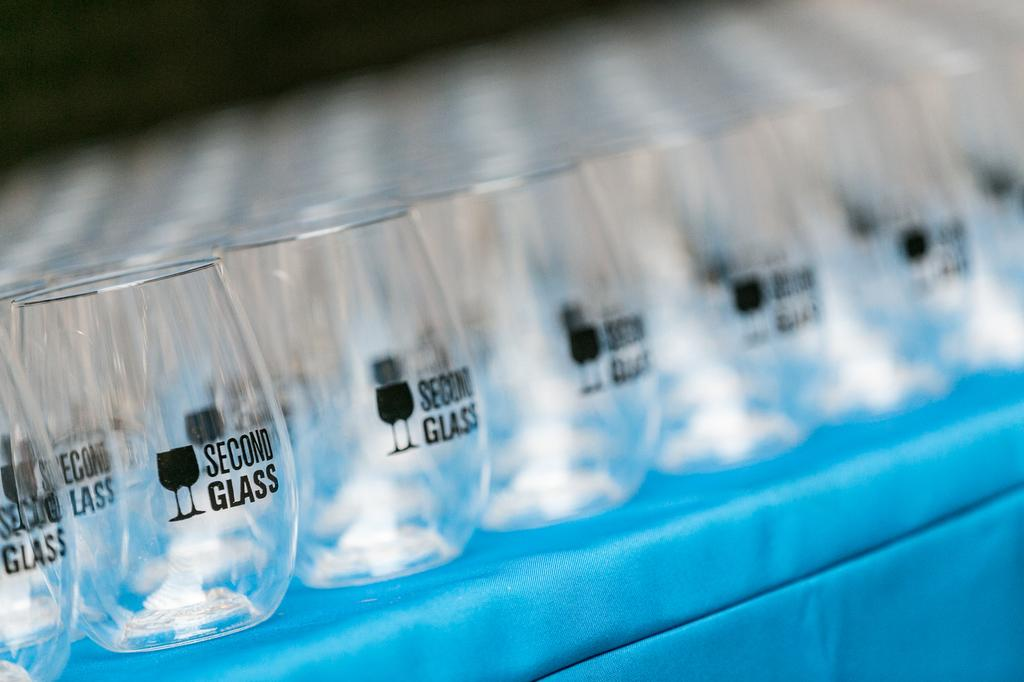Provide a one-sentence caption for the provided image. Numerous short glasses that say Second Glass are placed together on a table. 